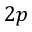Convert formula to latex. <formula><loc_0><loc_0><loc_500><loc_500>2 p</formula> 